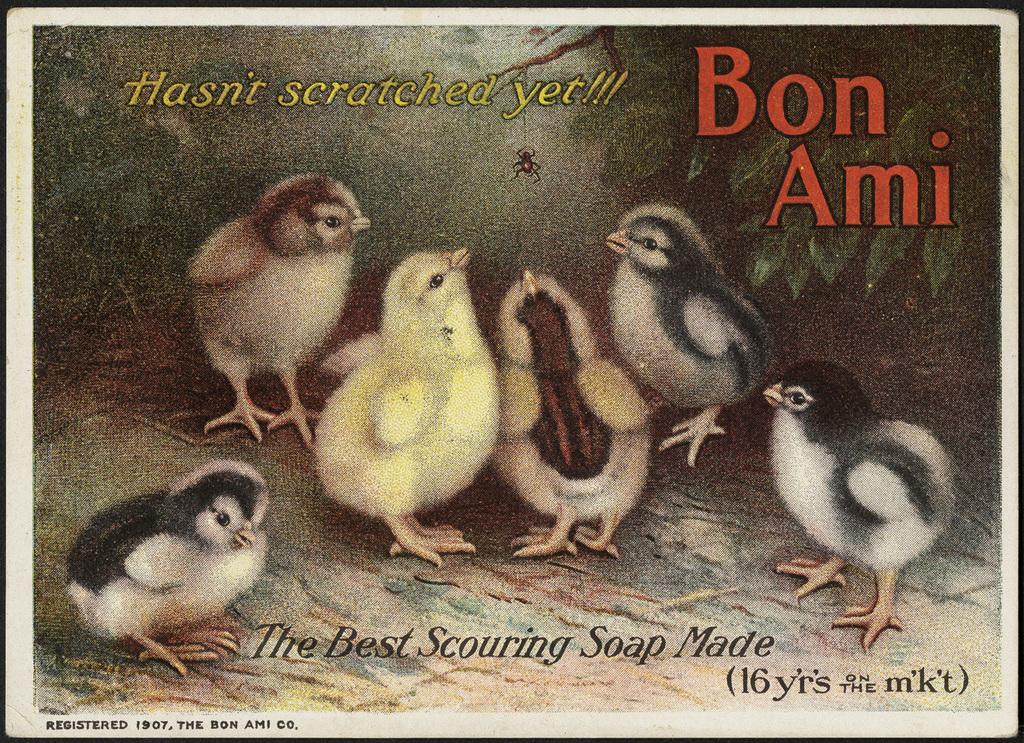What type of animals can be seen in the image? There are birds in the image. What else is present in the image besides the birds? There is text written on the image. What type of rings can be seen on the actor's fingers in the image? There is no actor or rings present in the image; it features birds and text. What type of guitar is being played by the musician in the image? There is no musician or guitar present in the image. 